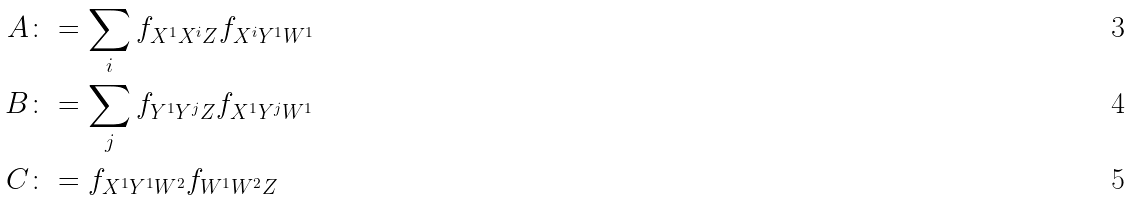Convert formula to latex. <formula><loc_0><loc_0><loc_500><loc_500>A & \colon = \sum _ { i } f _ { X ^ { 1 } X ^ { i } Z } f _ { X ^ { i } Y ^ { 1 } W ^ { 1 } } \\ B & \colon = \sum _ { j } f _ { Y ^ { 1 } Y ^ { j } Z } f _ { X ^ { 1 } Y ^ { j } W ^ { 1 } } \\ C & \colon = f _ { X ^ { 1 } Y ^ { 1 } W ^ { 2 } } f _ { W ^ { 1 } W ^ { 2 } Z }</formula> 